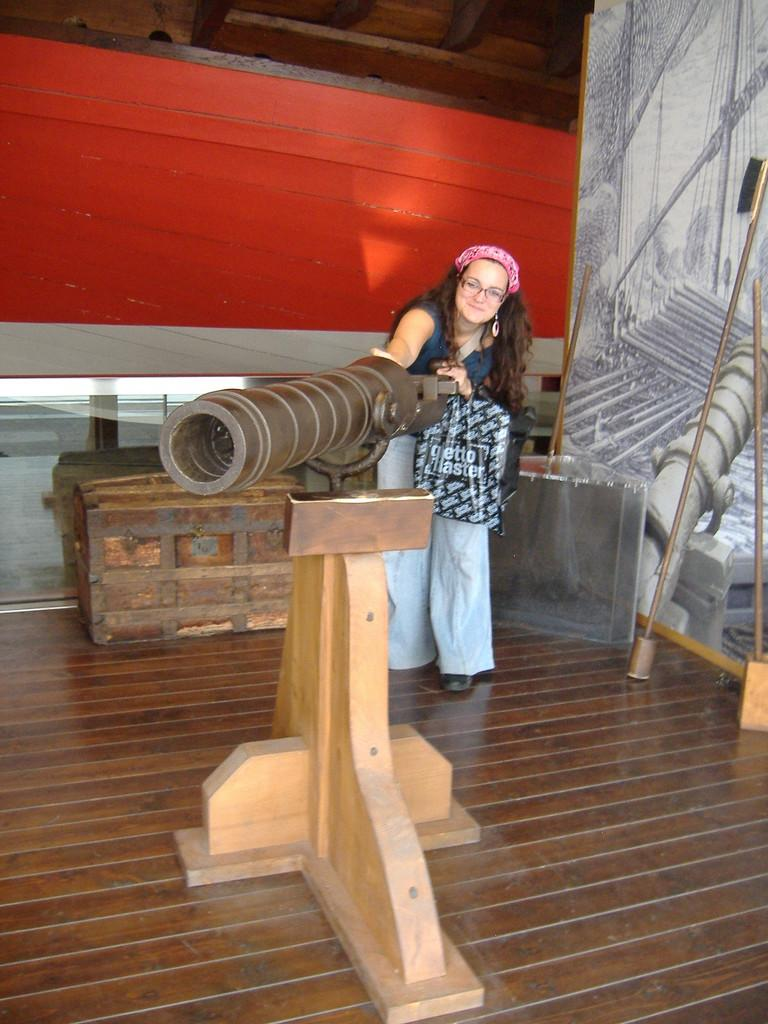Who is present in the image? There is a woman in the image. What is the woman doing in the image? The woman is standing near a cannon, smiling, and giving a pose. What can be seen in the background of the image? There is a wooden box visible in the background. What color is the wall behind the woman? The wall behind the woman is red. What is present in the right corner of the image? There is a banner on the right corner of the image. What type of jewel is the woman wearing on her skirt in the image? There is no mention of a jewel or a skirt in the image; the woman is wearing a red dress and standing near a cannon. 